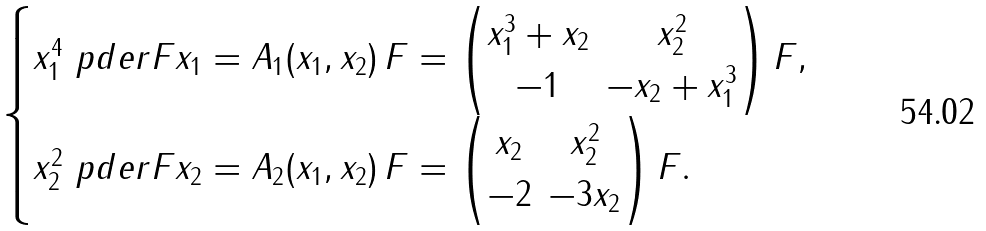Convert formula to latex. <formula><loc_0><loc_0><loc_500><loc_500>\begin{cases} x _ { 1 } ^ { 4 } \ p d e r { F } { x _ { 1 } } = A _ { 1 } ( x _ { 1 } , x _ { 2 } ) \, F = \left ( \begin{matrix} x _ { 1 } ^ { 3 } + x _ { 2 } & x _ { 2 } ^ { 2 } \\ - 1 & - x _ { 2 } + x _ { 1 } ^ { 3 } \end{matrix} \right ) F , \\ x _ { 2 } ^ { 2 } \ p d e r { F } { x _ { 2 } } = A _ { 2 } ( x _ { 1 } , x _ { 2 } ) \, F = \left ( \begin{matrix} x _ { 2 } & x _ { 2 } ^ { 2 } \\ - 2 & - 3 x _ { 2 } \end{matrix} \right ) F . \end{cases}</formula> 